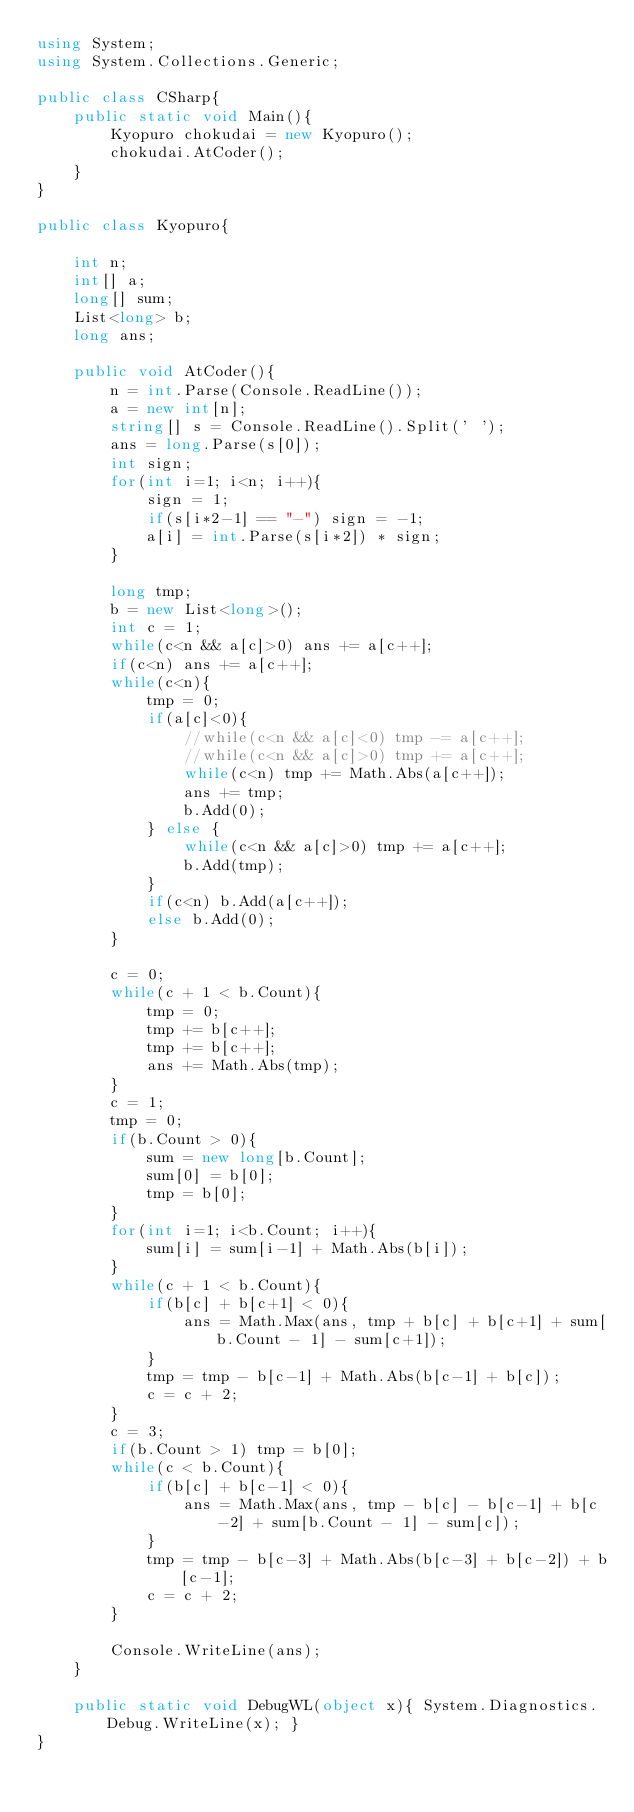Convert code to text. <code><loc_0><loc_0><loc_500><loc_500><_C#_>using System;
using System.Collections.Generic;

public class CSharp{
    public static void Main(){
        Kyopuro chokudai = new Kyopuro();
	    chokudai.AtCoder();
	}
}

public class Kyopuro{
    
    int n;
    int[] a;
    long[] sum;
    List<long> b;
    long ans;
    
    public void AtCoder(){
        n = int.Parse(Console.ReadLine());
        a = new int[n];
        string[] s = Console.ReadLine().Split(' ');
        ans = long.Parse(s[0]);
        int sign;
        for(int i=1; i<n; i++){
            sign = 1;
            if(s[i*2-1] == "-") sign = -1;
            a[i] = int.Parse(s[i*2]) * sign;
        }
        
        long tmp;
        b = new List<long>();
        int c = 1;
        while(c<n && a[c]>0) ans += a[c++];
        if(c<n) ans += a[c++];
        while(c<n){
            tmp = 0;
            if(a[c]<0){
                //while(c<n && a[c]<0) tmp -= a[c++];
                //while(c<n && a[c]>0) tmp += a[c++];
                while(c<n) tmp += Math.Abs(a[c++]);
                ans += tmp;
                b.Add(0);
            } else {
                while(c<n && a[c]>0) tmp += a[c++];
                b.Add(tmp);
            }
            if(c<n) b.Add(a[c++]);
            else b.Add(0);
        }
        
        c = 0;
        while(c + 1 < b.Count){
            tmp = 0;
            tmp += b[c++];
            tmp += b[c++];
            ans += Math.Abs(tmp);
        }
        c = 1;
        tmp = 0;
        if(b.Count > 0){
            sum = new long[b.Count];
            sum[0] = b[0];
            tmp = b[0];
        }
        for(int i=1; i<b.Count; i++){
            sum[i] = sum[i-1] + Math.Abs(b[i]);
        }
        while(c + 1 < b.Count){
            if(b[c] + b[c+1] < 0){
                ans = Math.Max(ans, tmp + b[c] + b[c+1] + sum[b.Count - 1] - sum[c+1]);
            }
            tmp = tmp - b[c-1] + Math.Abs(b[c-1] + b[c]);
            c = c + 2;
        }
        c = 3;
        if(b.Count > 1) tmp = b[0];
        while(c < b.Count){
            if(b[c] + b[c-1] < 0){
                ans = Math.Max(ans, tmp - b[c] - b[c-1] + b[c-2] + sum[b.Count - 1] - sum[c]);
            }
            tmp = tmp - b[c-3] + Math.Abs(b[c-3] + b[c-2]) + b[c-1];
            c = c + 2;
        }
        
        Console.WriteLine(ans);
    }
    
    public static void DebugWL(object x){ System.Diagnostics.Debug.WriteLine(x); }
}</code> 